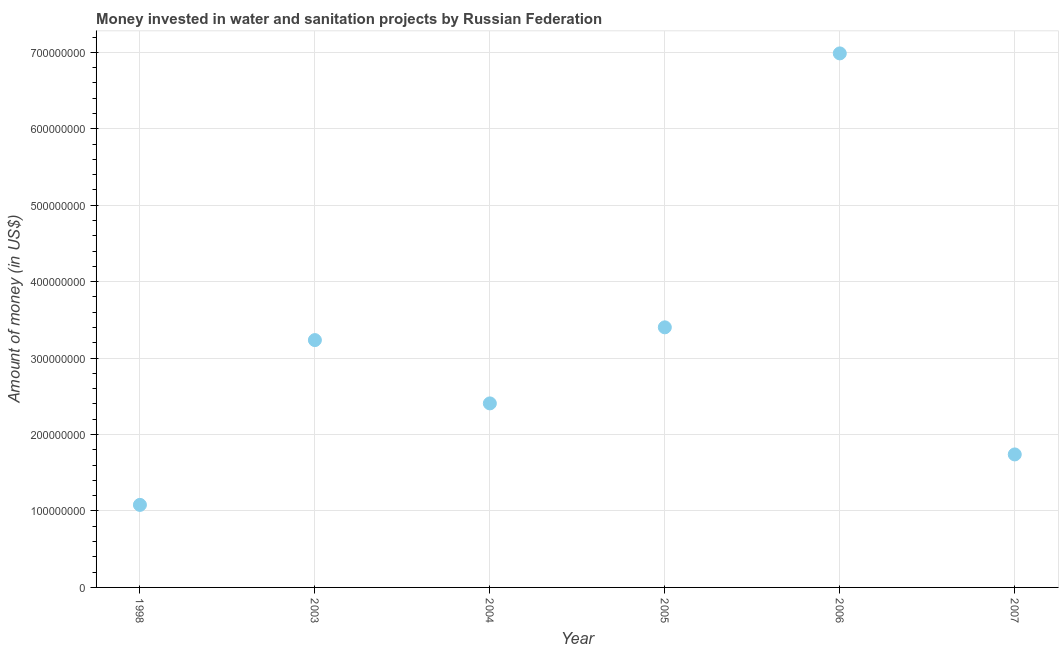What is the investment in 2007?
Provide a short and direct response. 1.74e+08. Across all years, what is the maximum investment?
Offer a terse response. 6.99e+08. Across all years, what is the minimum investment?
Give a very brief answer. 1.08e+08. In which year was the investment maximum?
Ensure brevity in your answer.  2006. What is the sum of the investment?
Give a very brief answer. 1.89e+09. What is the difference between the investment in 2004 and 2005?
Your response must be concise. -9.95e+07. What is the average investment per year?
Ensure brevity in your answer.  3.14e+08. What is the median investment?
Your answer should be very brief. 2.82e+08. What is the ratio of the investment in 2004 to that in 2005?
Provide a succinct answer. 0.71. Is the investment in 2005 less than that in 2007?
Keep it short and to the point. No. What is the difference between the highest and the second highest investment?
Your response must be concise. 3.58e+08. Is the sum of the investment in 1998 and 2005 greater than the maximum investment across all years?
Provide a short and direct response. No. What is the difference between the highest and the lowest investment?
Offer a terse response. 5.91e+08. Does the investment monotonically increase over the years?
Your answer should be compact. No. How many dotlines are there?
Give a very brief answer. 1. What is the difference between two consecutive major ticks on the Y-axis?
Ensure brevity in your answer.  1.00e+08. Does the graph contain any zero values?
Your answer should be very brief. No. Does the graph contain grids?
Your answer should be very brief. Yes. What is the title of the graph?
Provide a short and direct response. Money invested in water and sanitation projects by Russian Federation. What is the label or title of the X-axis?
Ensure brevity in your answer.  Year. What is the label or title of the Y-axis?
Make the answer very short. Amount of money (in US$). What is the Amount of money (in US$) in 1998?
Make the answer very short. 1.08e+08. What is the Amount of money (in US$) in 2003?
Your answer should be compact. 3.24e+08. What is the Amount of money (in US$) in 2004?
Your response must be concise. 2.41e+08. What is the Amount of money (in US$) in 2005?
Make the answer very short. 3.40e+08. What is the Amount of money (in US$) in 2006?
Ensure brevity in your answer.  6.99e+08. What is the Amount of money (in US$) in 2007?
Keep it short and to the point. 1.74e+08. What is the difference between the Amount of money (in US$) in 1998 and 2003?
Keep it short and to the point. -2.16e+08. What is the difference between the Amount of money (in US$) in 1998 and 2004?
Ensure brevity in your answer.  -1.33e+08. What is the difference between the Amount of money (in US$) in 1998 and 2005?
Ensure brevity in your answer.  -2.32e+08. What is the difference between the Amount of money (in US$) in 1998 and 2006?
Your answer should be very brief. -5.91e+08. What is the difference between the Amount of money (in US$) in 1998 and 2007?
Your response must be concise. -6.60e+07. What is the difference between the Amount of money (in US$) in 2003 and 2004?
Give a very brief answer. 8.28e+07. What is the difference between the Amount of money (in US$) in 2003 and 2005?
Your answer should be compact. -1.67e+07. What is the difference between the Amount of money (in US$) in 2003 and 2006?
Provide a succinct answer. -3.75e+08. What is the difference between the Amount of money (in US$) in 2003 and 2007?
Your response must be concise. 1.50e+08. What is the difference between the Amount of money (in US$) in 2004 and 2005?
Offer a very short reply. -9.95e+07. What is the difference between the Amount of money (in US$) in 2004 and 2006?
Your response must be concise. -4.58e+08. What is the difference between the Amount of money (in US$) in 2004 and 2007?
Offer a very short reply. 6.68e+07. What is the difference between the Amount of money (in US$) in 2005 and 2006?
Offer a very short reply. -3.58e+08. What is the difference between the Amount of money (in US$) in 2005 and 2007?
Your answer should be compact. 1.66e+08. What is the difference between the Amount of money (in US$) in 2006 and 2007?
Your response must be concise. 5.25e+08. What is the ratio of the Amount of money (in US$) in 1998 to that in 2003?
Provide a short and direct response. 0.33. What is the ratio of the Amount of money (in US$) in 1998 to that in 2004?
Ensure brevity in your answer.  0.45. What is the ratio of the Amount of money (in US$) in 1998 to that in 2005?
Your response must be concise. 0.32. What is the ratio of the Amount of money (in US$) in 1998 to that in 2006?
Keep it short and to the point. 0.15. What is the ratio of the Amount of money (in US$) in 1998 to that in 2007?
Your answer should be very brief. 0.62. What is the ratio of the Amount of money (in US$) in 2003 to that in 2004?
Provide a succinct answer. 1.34. What is the ratio of the Amount of money (in US$) in 2003 to that in 2005?
Offer a very short reply. 0.95. What is the ratio of the Amount of money (in US$) in 2003 to that in 2006?
Ensure brevity in your answer.  0.46. What is the ratio of the Amount of money (in US$) in 2003 to that in 2007?
Provide a succinct answer. 1.86. What is the ratio of the Amount of money (in US$) in 2004 to that in 2005?
Keep it short and to the point. 0.71. What is the ratio of the Amount of money (in US$) in 2004 to that in 2006?
Offer a terse response. 0.34. What is the ratio of the Amount of money (in US$) in 2004 to that in 2007?
Offer a very short reply. 1.38. What is the ratio of the Amount of money (in US$) in 2005 to that in 2006?
Provide a succinct answer. 0.49. What is the ratio of the Amount of money (in US$) in 2005 to that in 2007?
Provide a short and direct response. 1.96. What is the ratio of the Amount of money (in US$) in 2006 to that in 2007?
Your answer should be very brief. 4.02. 